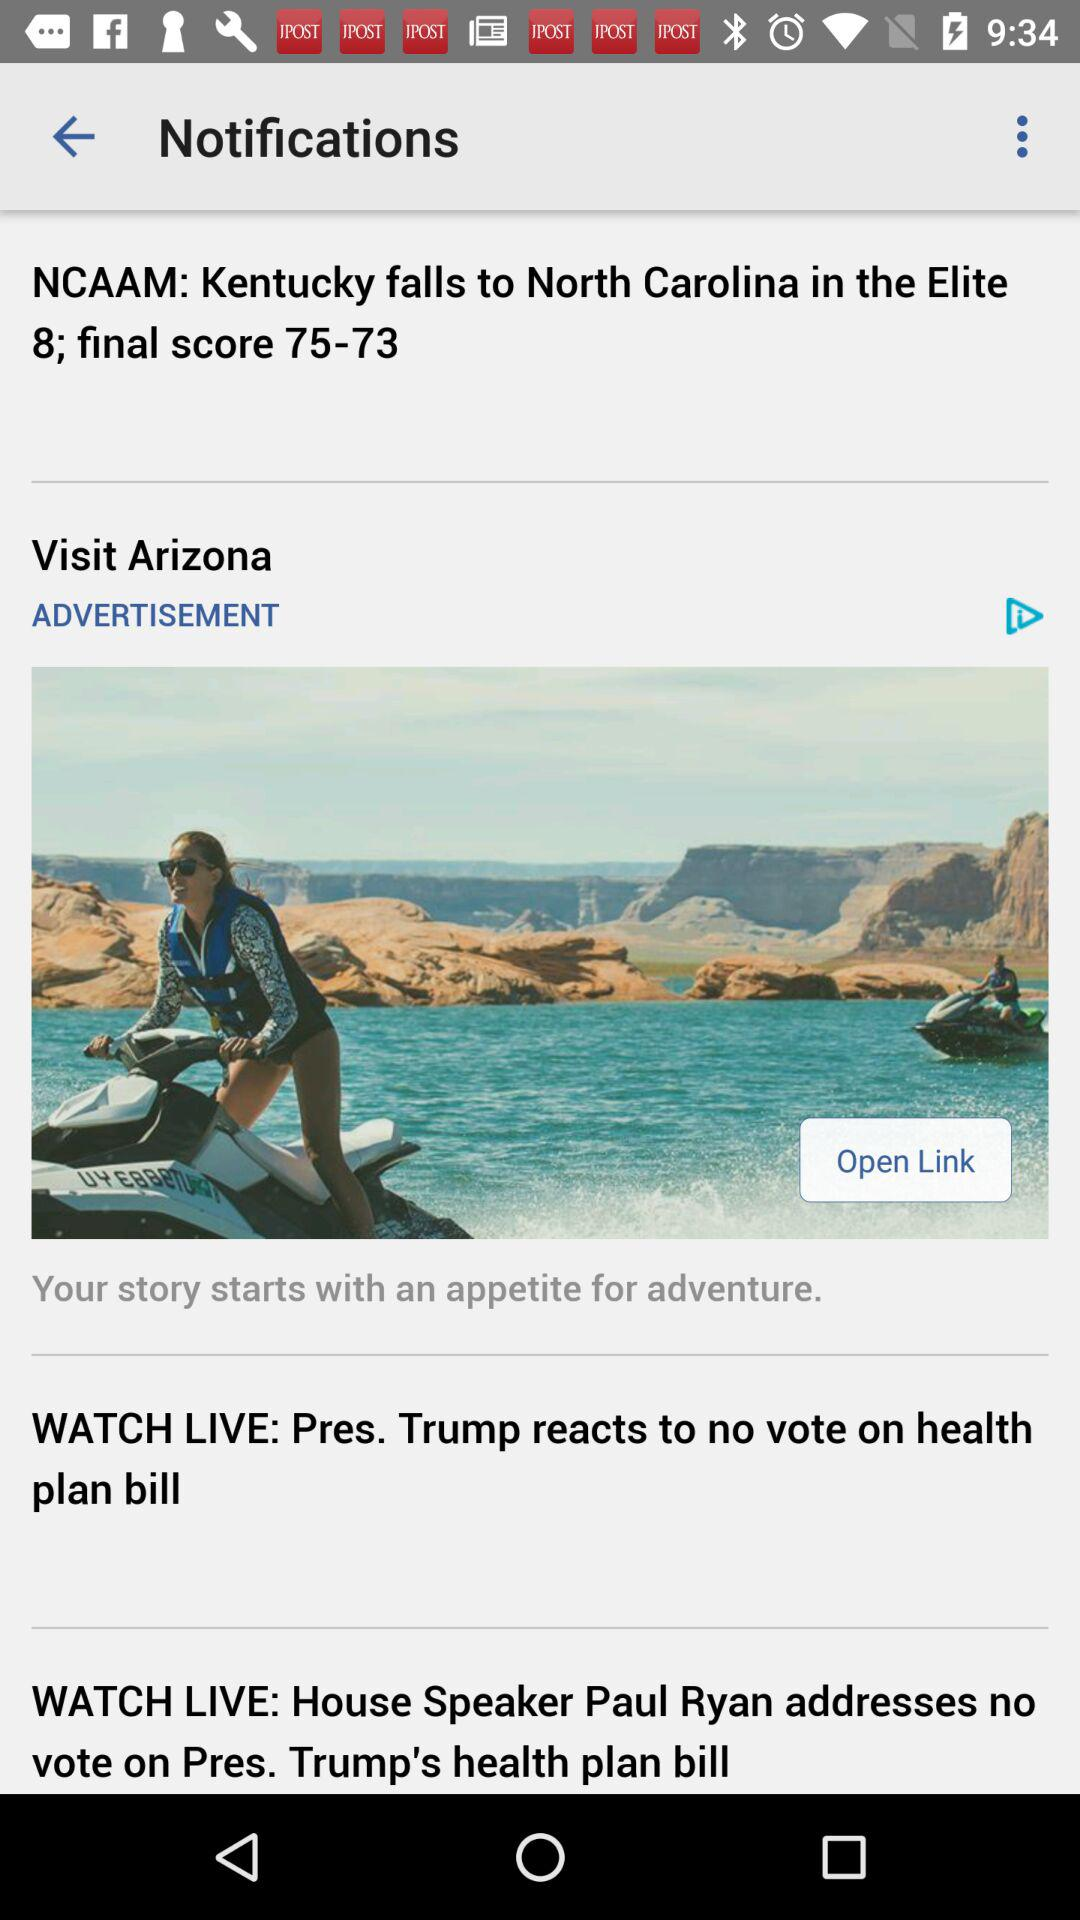What was the final score? The final scores were 75 and 73. 